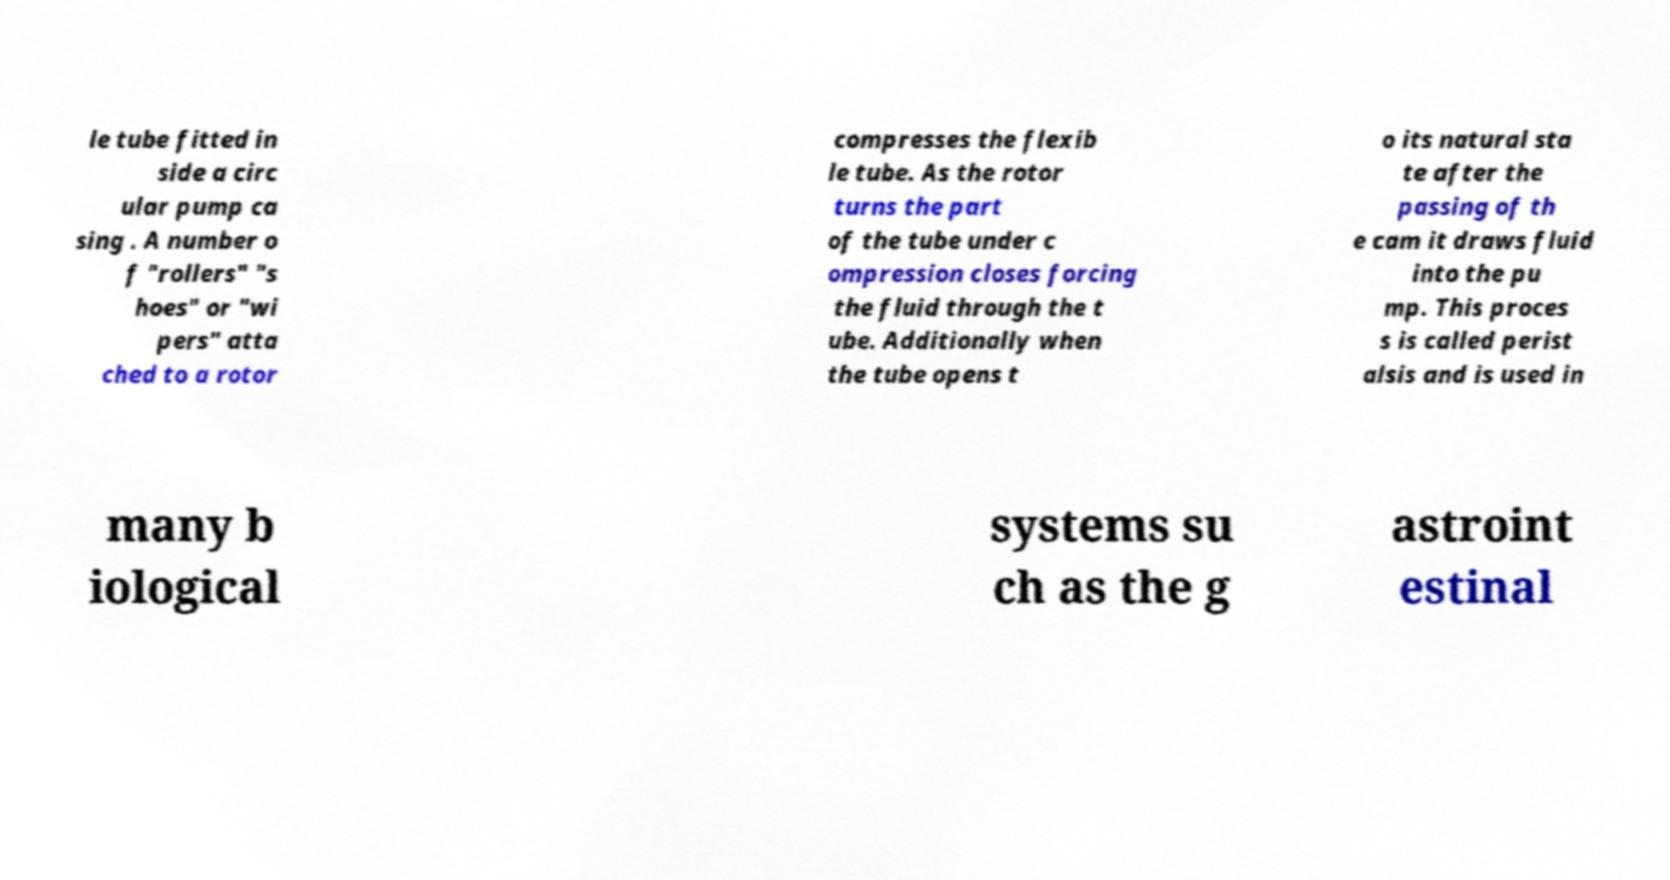I need the written content from this picture converted into text. Can you do that? le tube fitted in side a circ ular pump ca sing . A number o f "rollers" "s hoes" or "wi pers" atta ched to a rotor compresses the flexib le tube. As the rotor turns the part of the tube under c ompression closes forcing the fluid through the t ube. Additionally when the tube opens t o its natural sta te after the passing of th e cam it draws fluid into the pu mp. This proces s is called perist alsis and is used in many b iological systems su ch as the g astroint estinal 